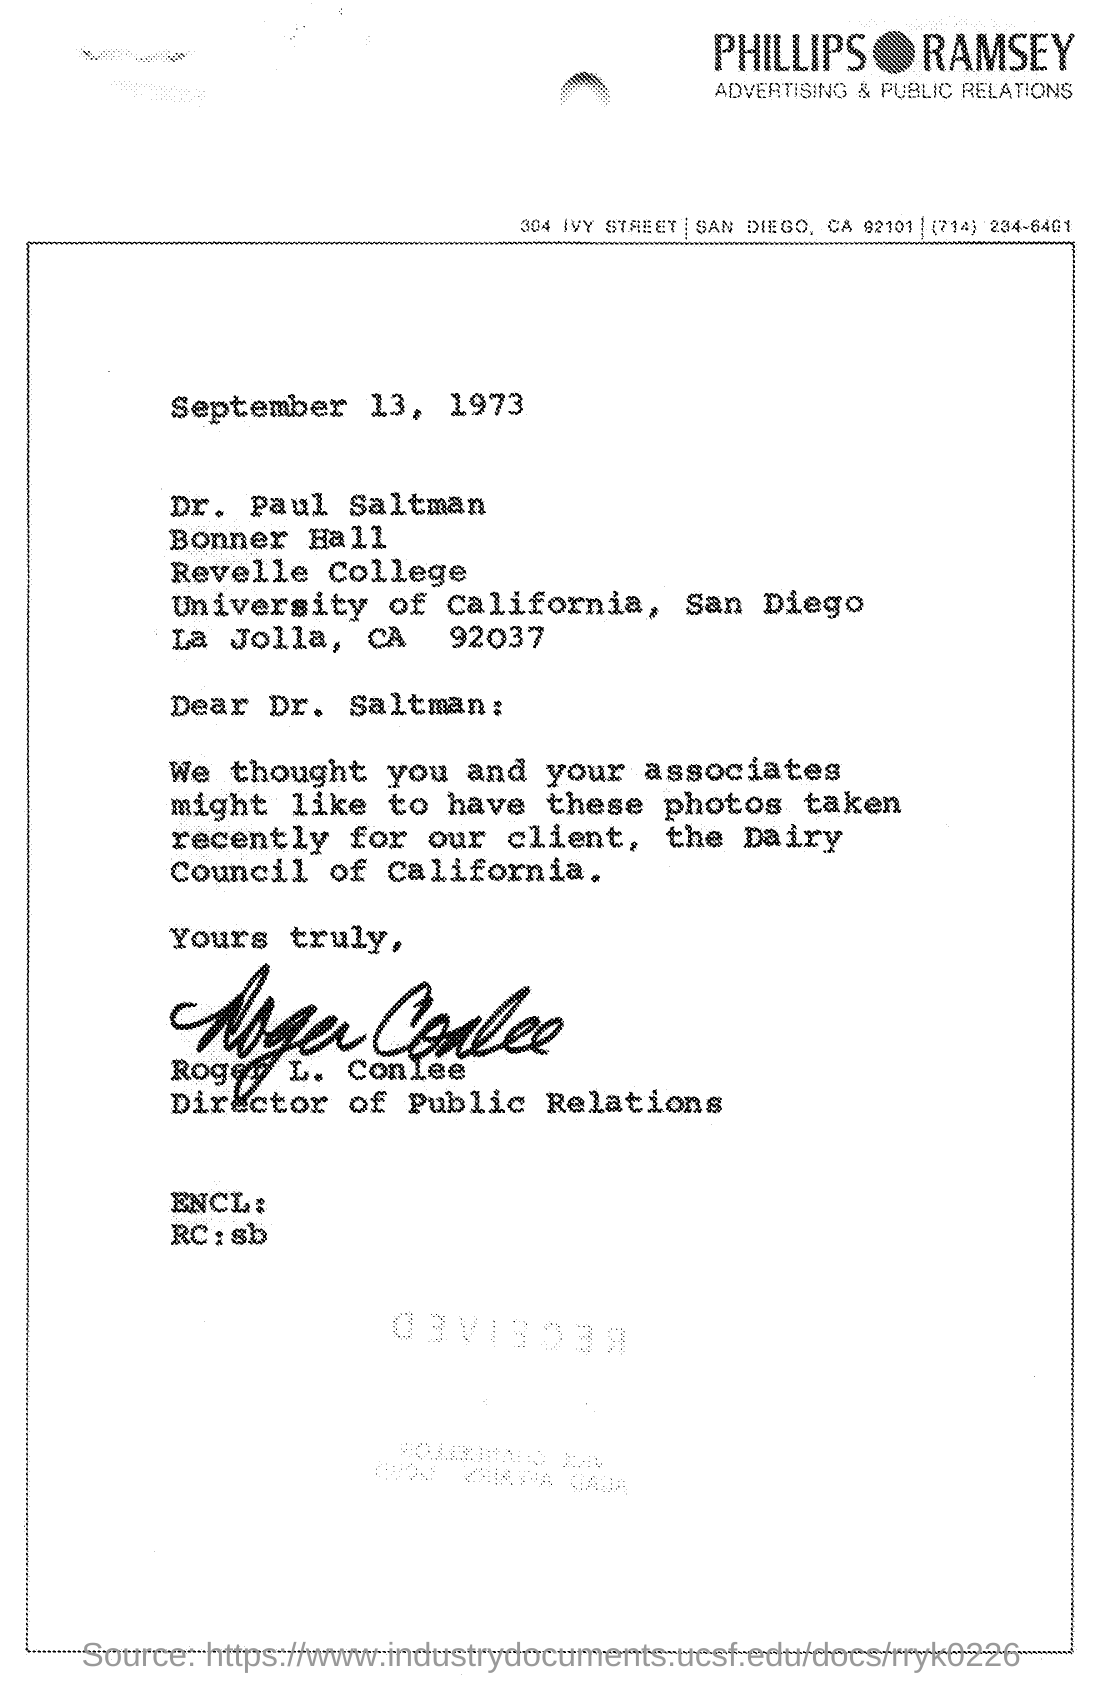What is the date mentioned in the given letter ?
Provide a short and direct response. September 13, 1973. Who's sign was there at the end of the letter ?
Offer a terse response. Roger L. Conlee. What is the designation of roger l. conlee ?
Provide a succinct answer. Director of public relations. What is the name of advertising & public relations as mentioned in the given page ?
Make the answer very short. Phillips Ramsey. 